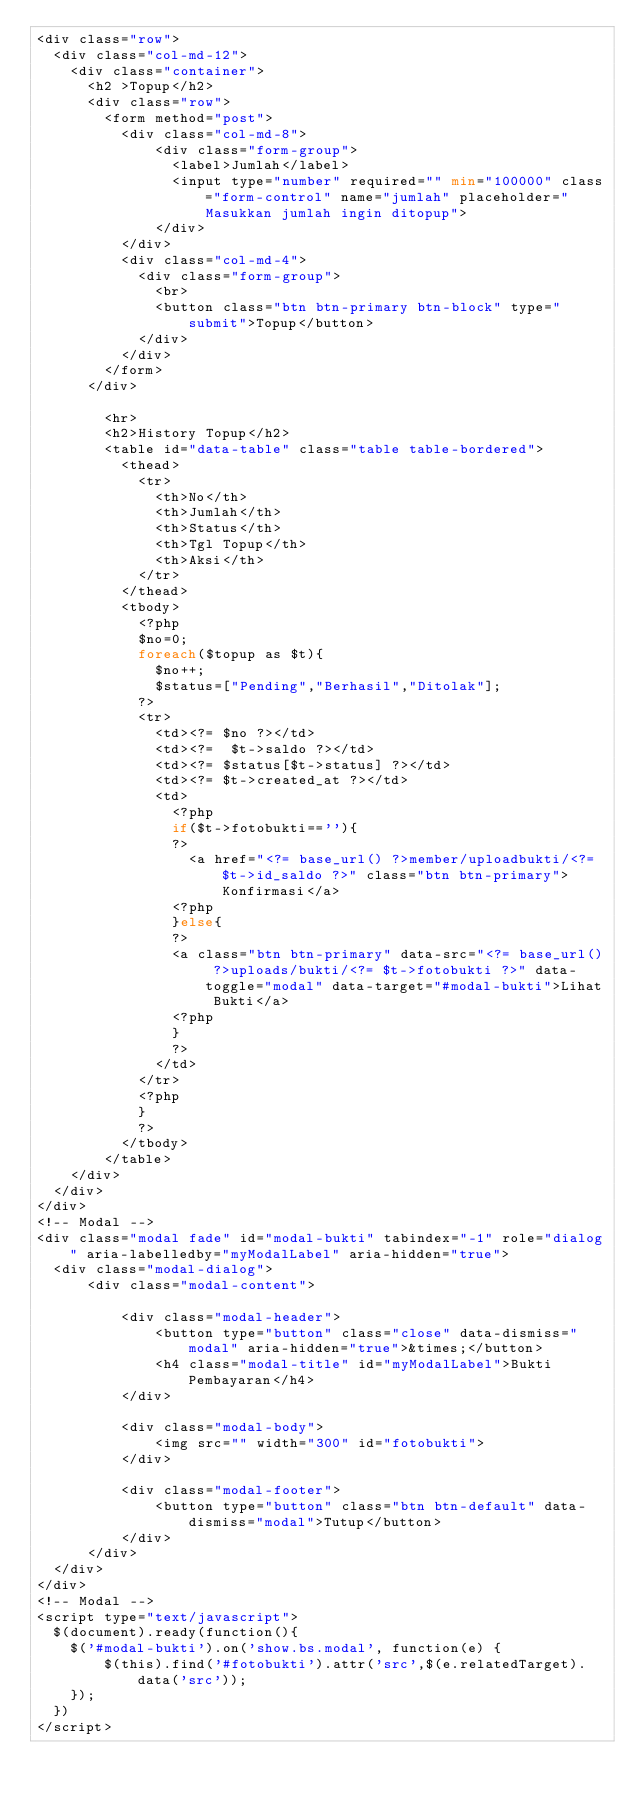Convert code to text. <code><loc_0><loc_0><loc_500><loc_500><_PHP_><div class="row">
  <div class="col-md-12">
    <div class="container">
      <h2 >Topup</h2>
      <div class="row">
        <form method="post">
          <div class="col-md-8">
              <div class="form-group">
                <label>Jumlah</label>
                <input type="number" required="" min="100000" class="form-control" name="jumlah" placeholder="Masukkan jumlah ingin ditopup">
              </div>
          </div>
          <div class="col-md-4">
            <div class="form-group">
              <br>
              <button class="btn btn-primary btn-block" type="submit">Topup</button>
            </div>
          </div>      
        </form>  
      </div>
      
        <hr>
        <h2>History Topup</h2>
        <table id="data-table" class="table table-bordered">
          <thead>
            <tr>
              <th>No</th>
              <th>Jumlah</th>
              <th>Status</th>
              <th>Tgl Topup</th>
              <th>Aksi</th>
            </tr>
          </thead>
          <tbody>
            <?php
            $no=0;
            foreach($topup as $t){
              $no++;
              $status=["Pending","Berhasil","Ditolak"];
            ?>
            <tr>
              <td><?= $no ?></td>
              <td><?=  $t->saldo ?></td>
              <td><?= $status[$t->status] ?></td>
              <td><?= $t->created_at ?></td>
              <td>
                <?php
                if($t->fotobukti==''){
                ?>
                  <a href="<?= base_url() ?>member/uploadbukti/<?= $t->id_saldo ?>" class="btn btn-primary">Konfirmasi</a>              
                <?php
                }else{
                ?>
                <a class="btn btn-primary" data-src="<?= base_url() ?>uploads/bukti/<?= $t->fotobukti ?>" data-toggle="modal" data-target="#modal-bukti">Lihat Bukti</a>
                <?php
                }
                ?>
              </td>
            </tr>
            <?php
            }
            ?>
          </tbody>
        </table>
    </div>
  </div>
</div>
<!-- Modal -->
<div class="modal fade" id="modal-bukti" tabindex="-1" role="dialog" aria-labelledby="myModalLabel" aria-hidden="true">
  <div class="modal-dialog">
      <div class="modal-content">
      
          <div class="modal-header">
              <button type="button" class="close" data-dismiss="modal" aria-hidden="true">&times;</button>
              <h4 class="modal-title" id="myModalLabel">Bukti Pembayaran</h4>
          </div>
      
          <div class="modal-body">
              <img src="" width="300" id="fotobukti">
          </div>
          
          <div class="modal-footer">
              <button type="button" class="btn btn-default" data-dismiss="modal">Tutup</button>
          </div>
      </div>
  </div>
</div>
<!-- Modal -->
<script type="text/javascript">
  $(document).ready(function(){
    $('#modal-bukti').on('show.bs.modal', function(e) {
        $(this).find('#fotobukti').attr('src',$(e.relatedTarget).data('src'));
    });
  })
</script></code> 